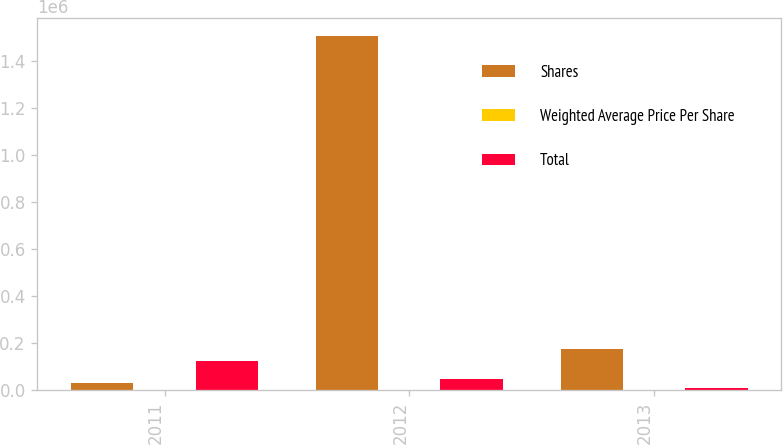<chart> <loc_0><loc_0><loc_500><loc_500><stacked_bar_chart><ecel><fcel>2011<fcel>2012<fcel>2013<nl><fcel>Shares<fcel>26480.5<fcel>1.50766e+06<fcel>171263<nl><fcel>Weighted Average Price Per Share<fcel>25.51<fcel>29.96<fcel>45.54<nl><fcel>Total<fcel>123077<fcel>45162<fcel>7799<nl></chart> 